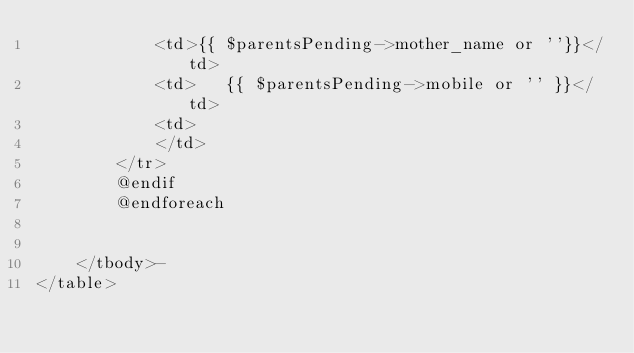Convert code to text. <code><loc_0><loc_0><loc_500><loc_500><_PHP_>			<td>{{ $parentsPending->mother_name or ''}}</td>
			<td>   {{ $parentsPending->mobile or '' }}</td>
			<td>  
			</td>
		</tr> 
		@endif
		@endforeach
		

	</tbody>-
</table>
</code> 